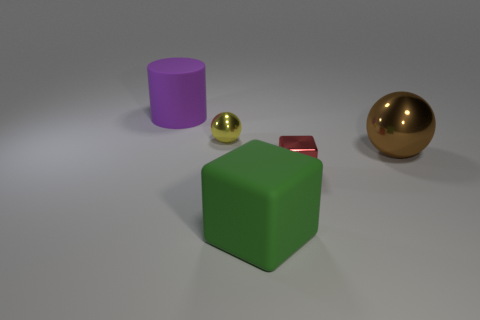Is there any indication of what time of day it is or where these objects might be located? The image seems to be a controlled studio setting without any clear indicators of time of day. There's soft diffused lighting that highlights the objects without casting harsh shadows, typical of indoor photography or rendering designed to focus on the objects themselves without environmental context. Is there anything in the image that indicates its purpose or the intention behind its arrangement? The image appears to be a simplistic arrangement of objects, possibly for a study of color, shape, and material in 3D modeling or a visual demonstration. There are no discernible elements that would suggest a practical purpose beyond an artistic or educational display of these properties. 